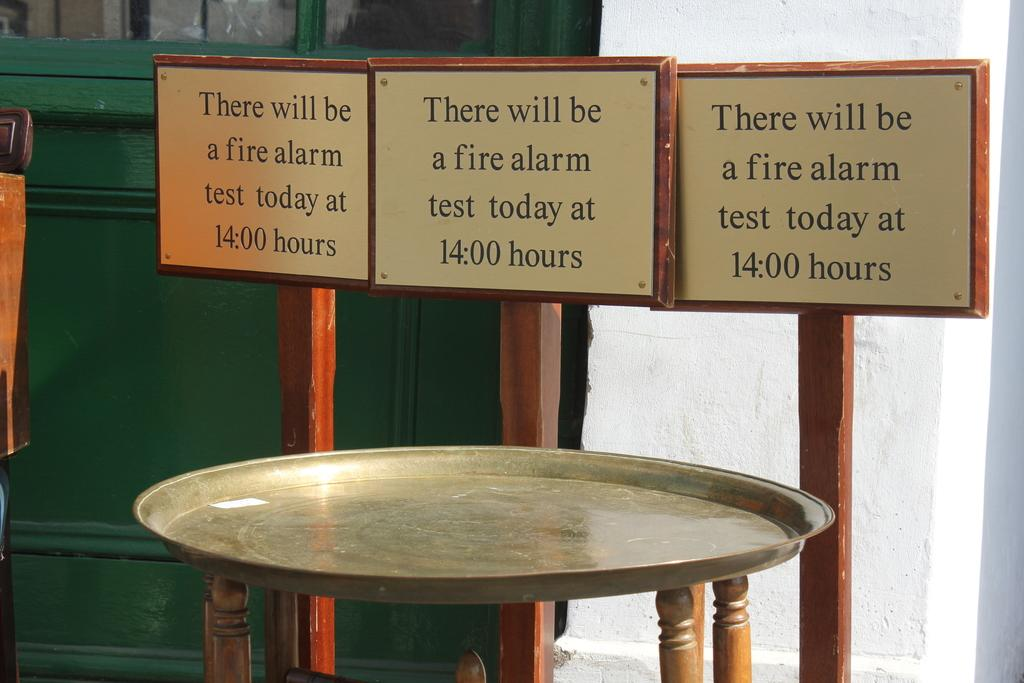What type of furniture is present in the image? There is a table in the image. What can be seen on the boards in the background? The boards in the background have text on them. What type of structure is visible in the image? There is a wall visible in the image. How many screws are holding the table together in the image? There is no information about screws in the image, so we cannot determine how many are holding the table together. 